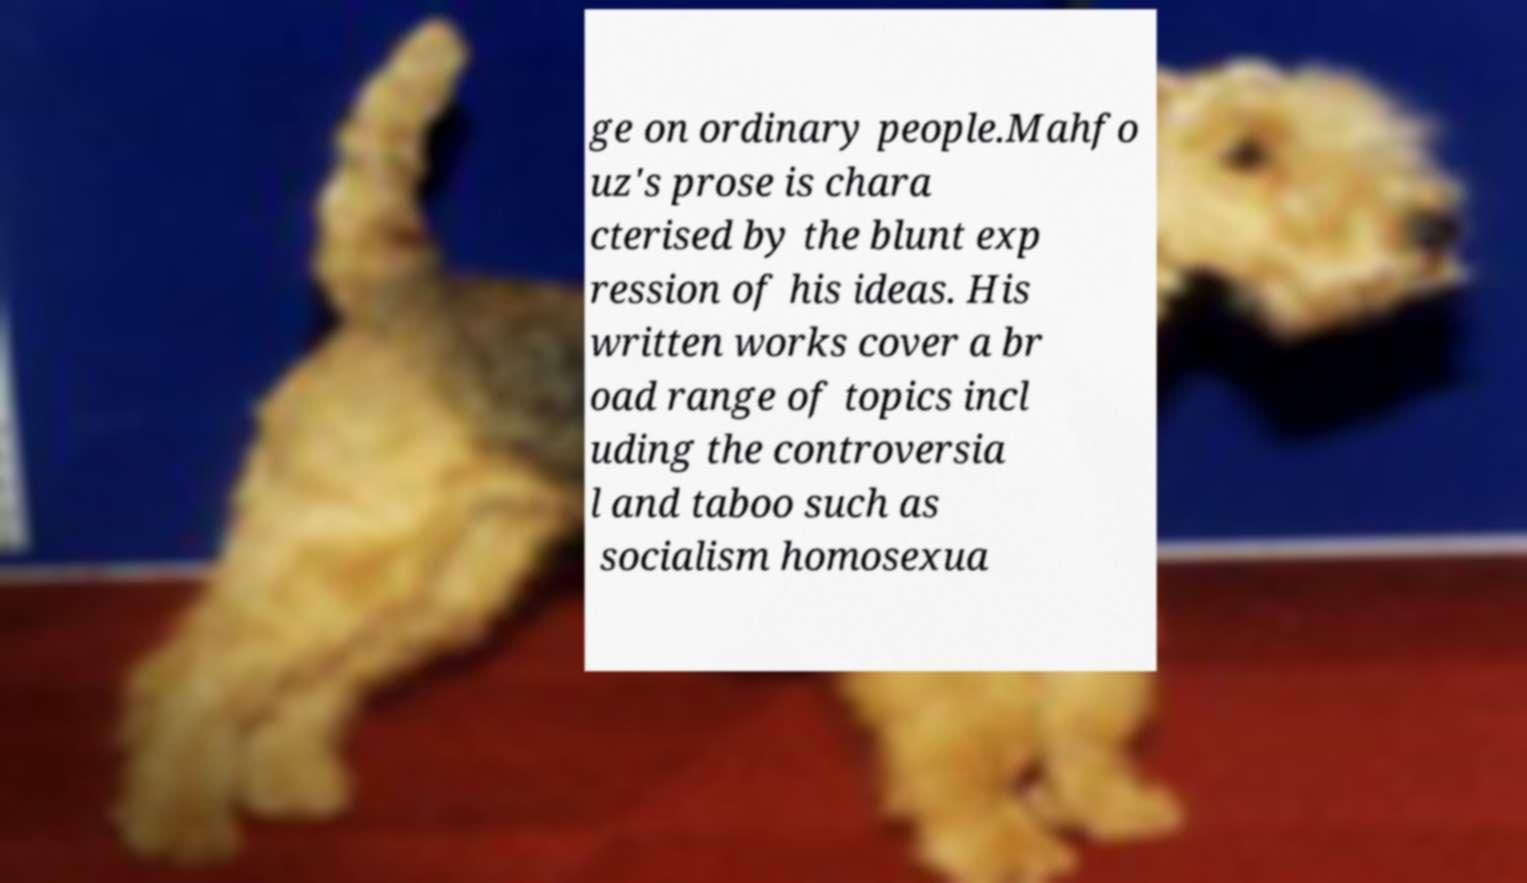What messages or text are displayed in this image? I need them in a readable, typed format. ge on ordinary people.Mahfo uz's prose is chara cterised by the blunt exp ression of his ideas. His written works cover a br oad range of topics incl uding the controversia l and taboo such as socialism homosexua 